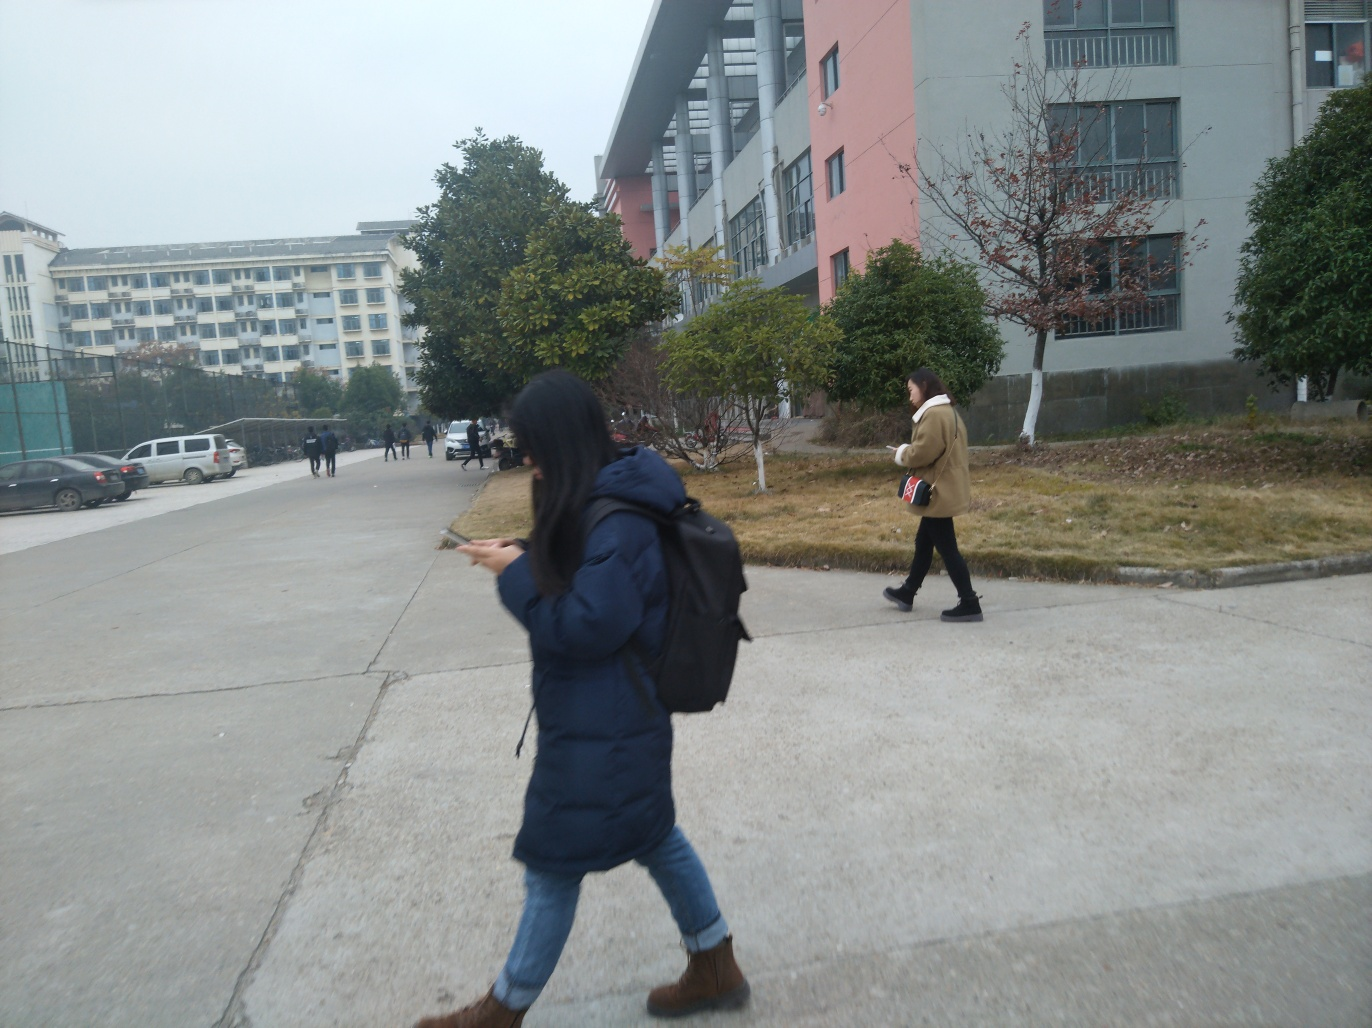Can you describe the setting of the image? The setting is an urban environment with a wide street. There are buildings indicative of a campus or institutional setting, such as what might be found on a university campus or a similar establishment. The presence of other pedestrians in the background adds to the sense of daily life and routine associated with such environments. 